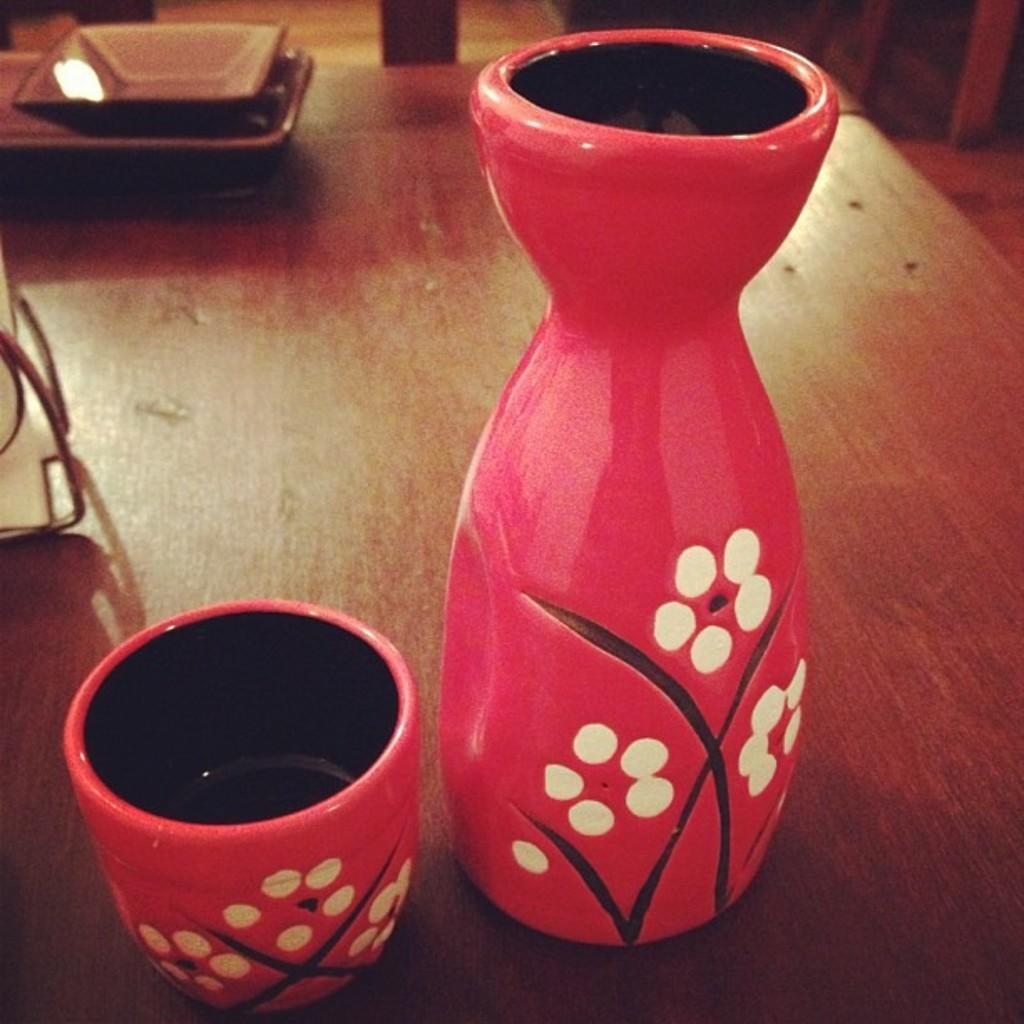What color is the cup in the image? The cup in the image is red. What other red object can be seen in the image? There is a red color pot in the image. What color are the things in the background of the image? The things in the background of the image are brown. What color is the white color object in the image? The white color object in the image is white. How many sheep are visible in the image? There are no sheep present in the image. What event is taking place in the image related to birth? There is no event related to birth depicted in the image. 